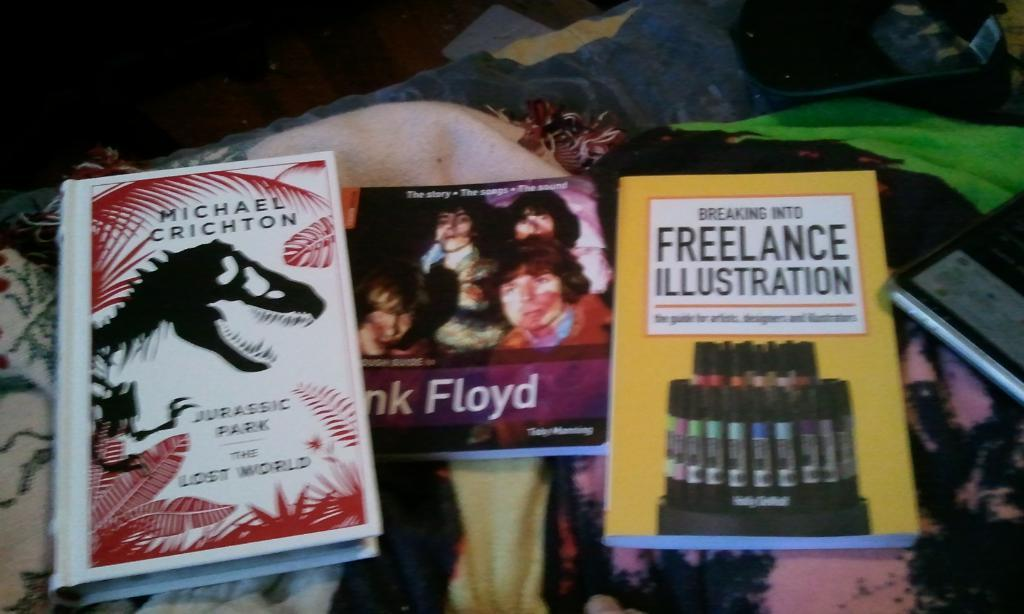<image>
Give a short and clear explanation of the subsequent image. Some books like Jurassic Park and Breaking Into Freelance Illustration lying on some colorful clothes 